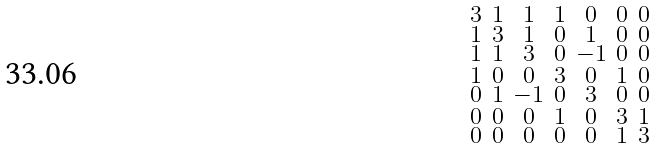Convert formula to latex. <formula><loc_0><loc_0><loc_500><loc_500>\begin{smallmatrix} 3 & 1 & 1 & 1 & 0 & 0 & 0 \\ 1 & 3 & 1 & 0 & 1 & 0 & 0 \\ 1 & 1 & 3 & 0 & - 1 & 0 & 0 \\ 1 & 0 & 0 & 3 & 0 & 1 & 0 \\ 0 & 1 & - 1 & 0 & 3 & 0 & 0 \\ 0 & 0 & 0 & 1 & 0 & 3 & 1 \\ 0 & 0 & 0 & 0 & 0 & 1 & 3 \end{smallmatrix}</formula> 